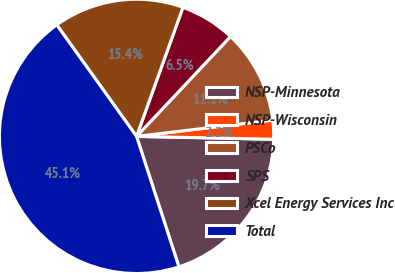Convert chart to OTSL. <chart><loc_0><loc_0><loc_500><loc_500><pie_chart><fcel>NSP-Minnesota<fcel>NSP-Wisconsin<fcel>PSCo<fcel>SPS<fcel>Xcel Energy Services Inc<fcel>Total<nl><fcel>19.67%<fcel>2.23%<fcel>11.09%<fcel>6.52%<fcel>15.38%<fcel>45.11%<nl></chart> 